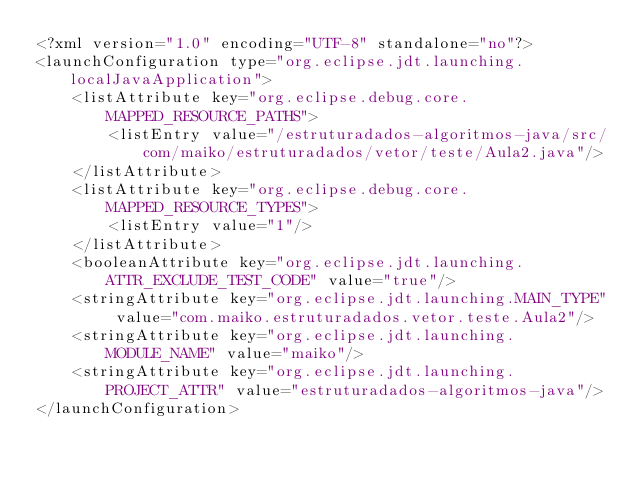Convert code to text. <code><loc_0><loc_0><loc_500><loc_500><_XML_><?xml version="1.0" encoding="UTF-8" standalone="no"?>
<launchConfiguration type="org.eclipse.jdt.launching.localJavaApplication">
    <listAttribute key="org.eclipse.debug.core.MAPPED_RESOURCE_PATHS">
        <listEntry value="/estruturadados-algoritmos-java/src/com/maiko/estruturadados/vetor/teste/Aula2.java"/>
    </listAttribute>
    <listAttribute key="org.eclipse.debug.core.MAPPED_RESOURCE_TYPES">
        <listEntry value="1"/>
    </listAttribute>
    <booleanAttribute key="org.eclipse.jdt.launching.ATTR_EXCLUDE_TEST_CODE" value="true"/>
    <stringAttribute key="org.eclipse.jdt.launching.MAIN_TYPE" value="com.maiko.estruturadados.vetor.teste.Aula2"/>
    <stringAttribute key="org.eclipse.jdt.launching.MODULE_NAME" value="maiko"/>
    <stringAttribute key="org.eclipse.jdt.launching.PROJECT_ATTR" value="estruturadados-algoritmos-java"/>
</launchConfiguration>
</code> 